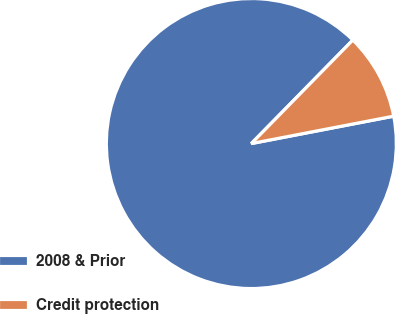Convert chart. <chart><loc_0><loc_0><loc_500><loc_500><pie_chart><fcel>2008 & Prior<fcel>Credit protection<nl><fcel>90.37%<fcel>9.63%<nl></chart> 